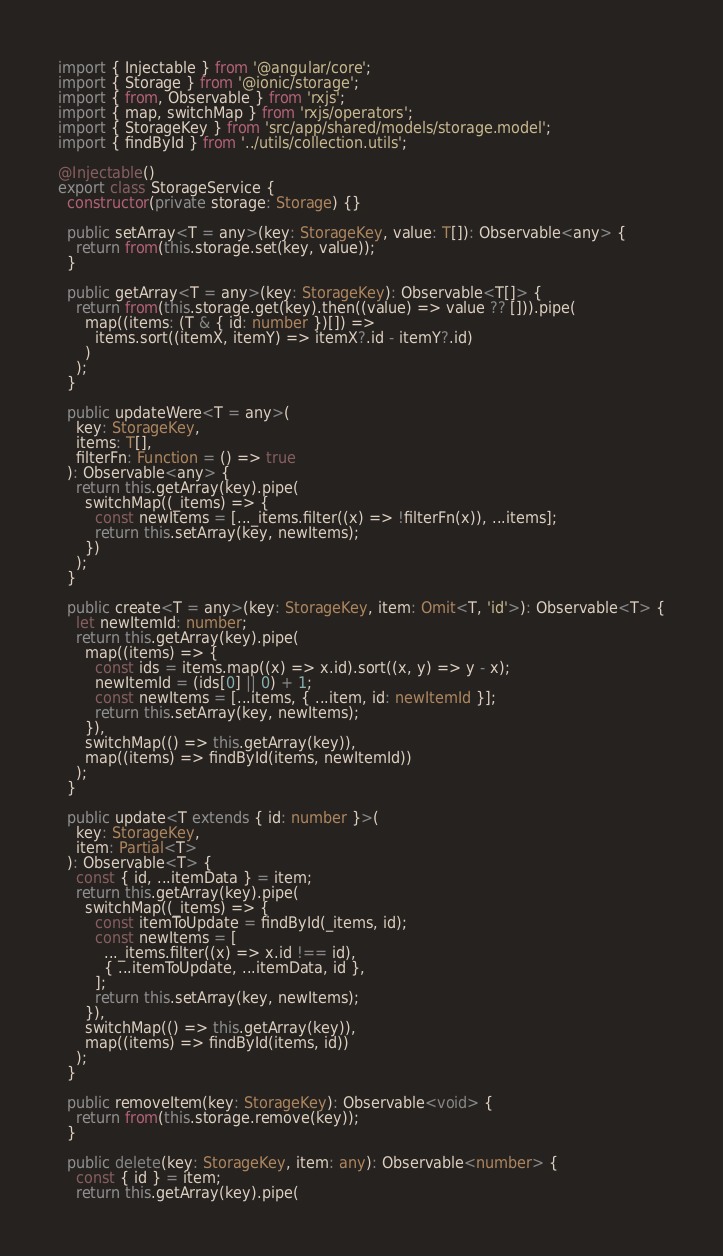Convert code to text. <code><loc_0><loc_0><loc_500><loc_500><_TypeScript_>import { Injectable } from '@angular/core';
import { Storage } from '@ionic/storage';
import { from, Observable } from 'rxjs';
import { map, switchMap } from 'rxjs/operators';
import { StorageKey } from 'src/app/shared/models/storage.model';
import { findById } from '../utils/collection.utils';

@Injectable()
export class StorageService {
  constructor(private storage: Storage) {}

  public setArray<T = any>(key: StorageKey, value: T[]): Observable<any> {
    return from(this.storage.set(key, value));
  }

  public getArray<T = any>(key: StorageKey): Observable<T[]> {
    return from(this.storage.get(key).then((value) => value ?? [])).pipe(
      map((items: (T & { id: number })[]) =>
        items.sort((itemX, itemY) => itemX?.id - itemY?.id)
      )
    );
  }

  public updateWere<T = any>(
    key: StorageKey,
    items: T[],
    filterFn: Function = () => true
  ): Observable<any> {
    return this.getArray(key).pipe(
      switchMap((_items) => {
        const newItems = [..._items.filter((x) => !filterFn(x)), ...items];
        return this.setArray(key, newItems);
      })
    );
  }

  public create<T = any>(key: StorageKey, item: Omit<T, 'id'>): Observable<T> {
    let newItemId: number;
    return this.getArray(key).pipe(
      map((items) => {
        const ids = items.map((x) => x.id).sort((x, y) => y - x);
        newItemId = (ids[0] || 0) + 1;
        const newItems = [...items, { ...item, id: newItemId }];
        return this.setArray(key, newItems);
      }),
      switchMap(() => this.getArray(key)),
      map((items) => findById(items, newItemId))
    );
  }

  public update<T extends { id: number }>(
    key: StorageKey,
    item: Partial<T>
  ): Observable<T> {
    const { id, ...itemData } = item;
    return this.getArray(key).pipe(
      switchMap((_items) => {
        const itemToUpdate = findById(_items, id);
        const newItems = [
          ..._items.filter((x) => x.id !== id),
          { ...itemToUpdate, ...itemData, id },
        ];
        return this.setArray(key, newItems);
      }),
      switchMap(() => this.getArray(key)),
      map((items) => findById(items, id))
    );
  }

  public removeItem(key: StorageKey): Observable<void> {
    return from(this.storage.remove(key));
  }

  public delete(key: StorageKey, item: any): Observable<number> {
    const { id } = item;
    return this.getArray(key).pipe(</code> 